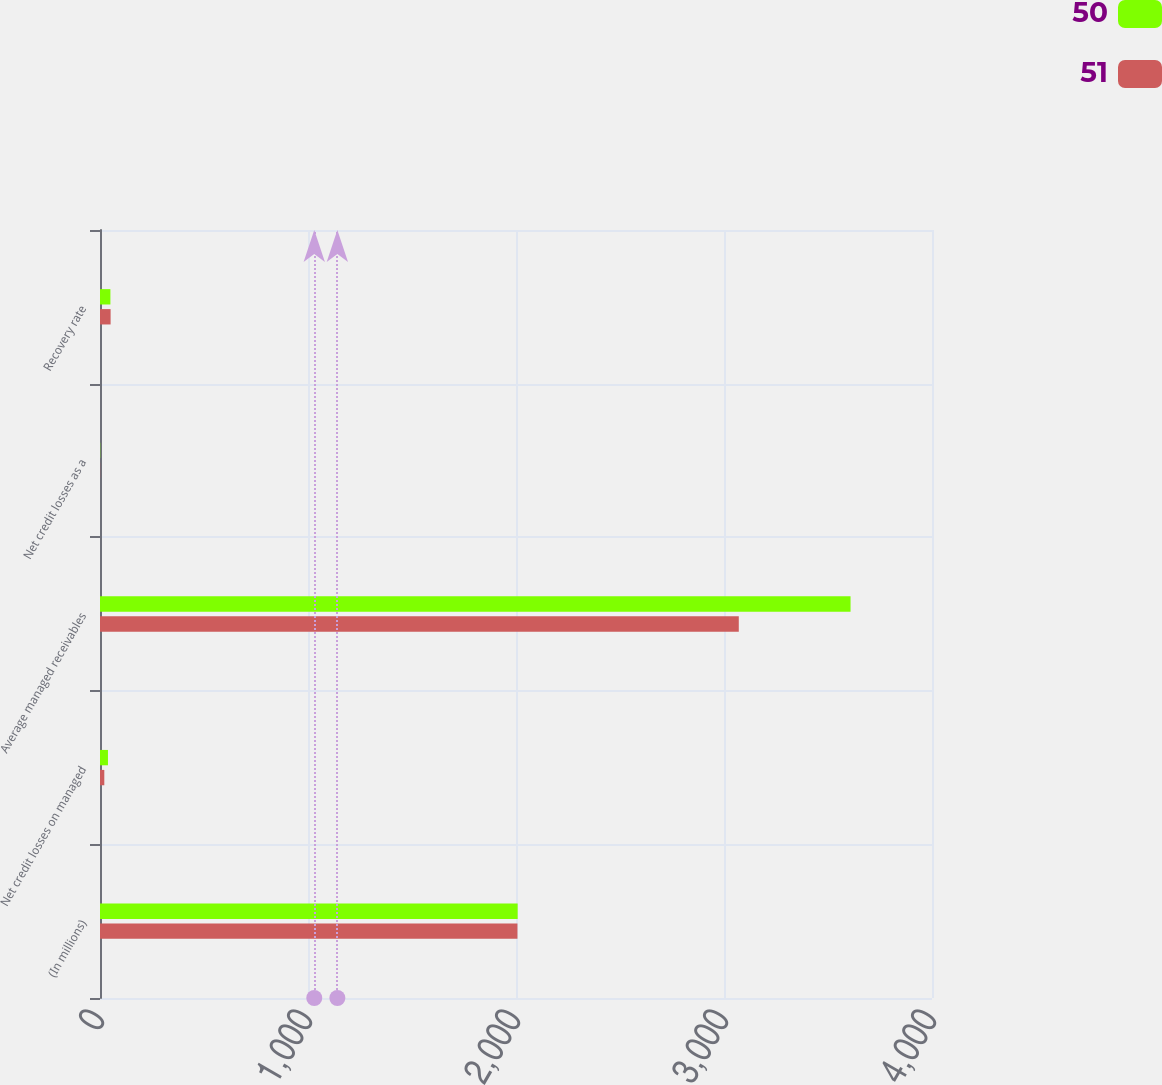<chart> <loc_0><loc_0><loc_500><loc_500><stacked_bar_chart><ecel><fcel>(In millions)<fcel>Net credit losses on managed<fcel>Average managed receivables<fcel>Net credit losses as a<fcel>Recovery rate<nl><fcel>50<fcel>2008<fcel>38.3<fcel>3608.4<fcel>1.06<fcel>50<nl><fcel>51<fcel>2007<fcel>20.7<fcel>3071.1<fcel>0.67<fcel>51<nl></chart> 